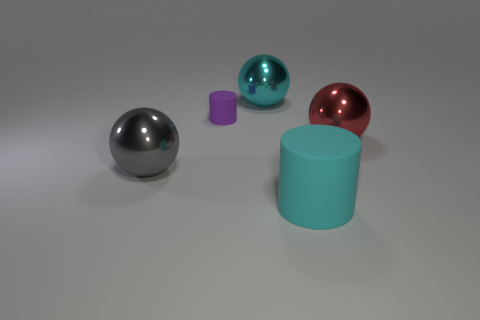What number of things are red metallic blocks or purple objects?
Offer a very short reply. 1. There is a cylinder behind the shiny ball right of the cyan thing to the left of the cyan rubber object; what is its size?
Ensure brevity in your answer.  Small. How many tiny objects have the same color as the large cylinder?
Make the answer very short. 0. What number of big cyan things are the same material as the red thing?
Ensure brevity in your answer.  1. What number of objects are either cyan matte objects or large cyan objects on the right side of the cyan shiny thing?
Your answer should be very brief. 1. There is a cylinder that is behind the large gray sphere in front of the matte thing behind the big cyan rubber thing; what is its color?
Give a very brief answer. Purple. There is a sphere that is right of the big matte object; how big is it?
Offer a terse response. Large. What number of small objects are either cyan matte objects or red rubber things?
Your answer should be compact. 0. What color is the thing that is both in front of the red metallic sphere and behind the cyan rubber cylinder?
Provide a succinct answer. Gray. Is there a gray metallic object of the same shape as the small purple matte object?
Provide a succinct answer. No. 